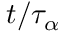<formula> <loc_0><loc_0><loc_500><loc_500>t / \tau _ { \alpha }</formula> 